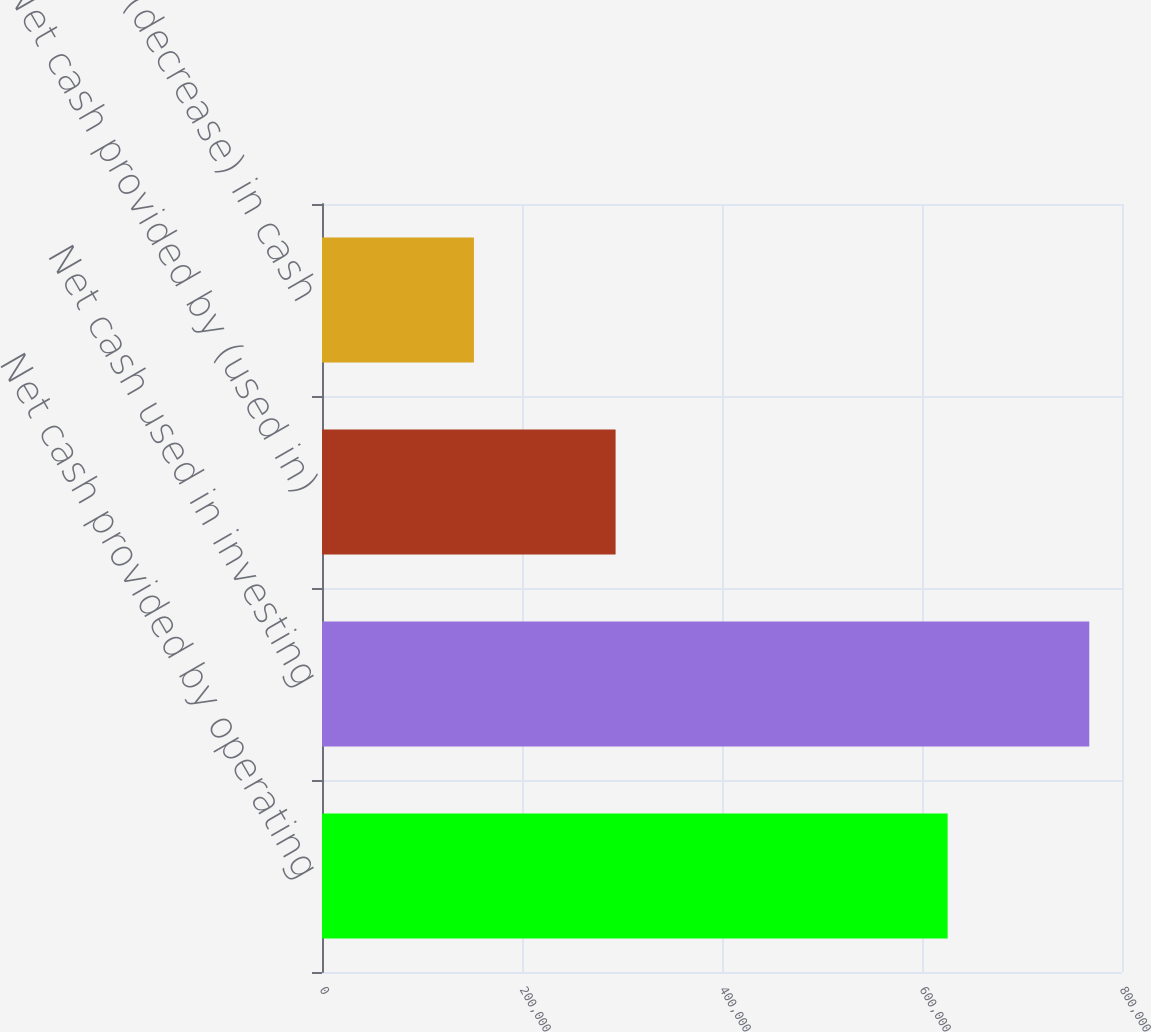Convert chart. <chart><loc_0><loc_0><loc_500><loc_500><bar_chart><fcel>Net cash provided by operating<fcel>Net cash used in investing<fcel>Net cash provided by (used in)<fcel>Increase (decrease) in cash<nl><fcel>625627<fcel>767276<fcel>293586<fcel>151937<nl></chart> 